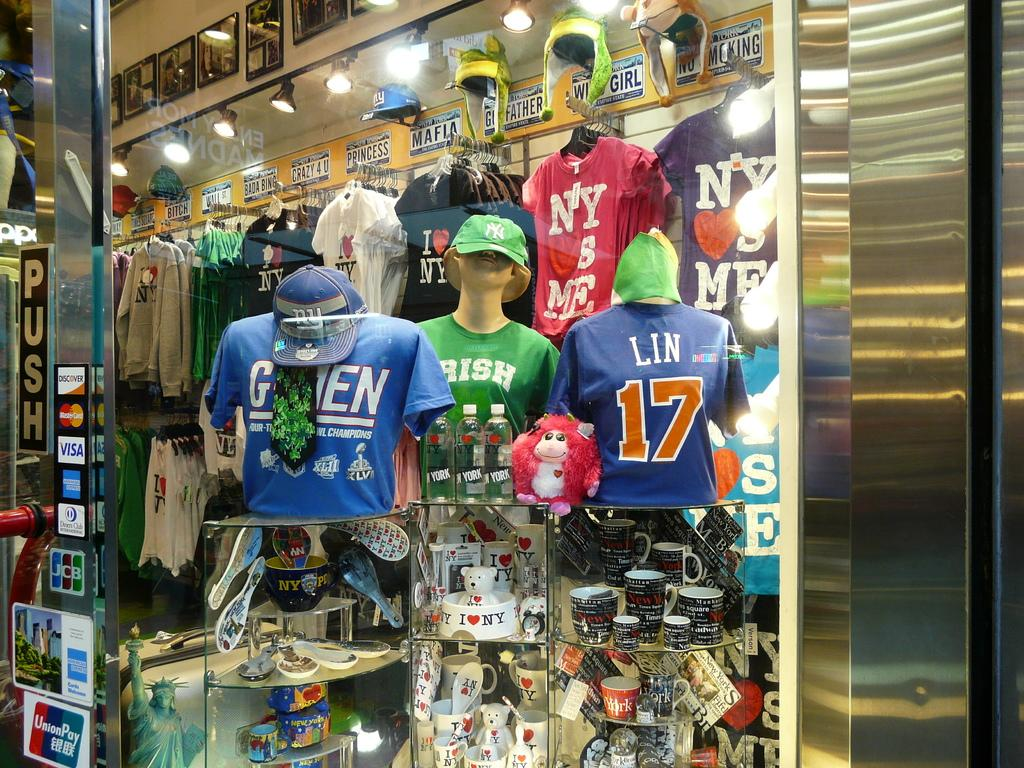<image>
Present a compact description of the photo's key features. A store takes Mastercard and Visa as payments. 